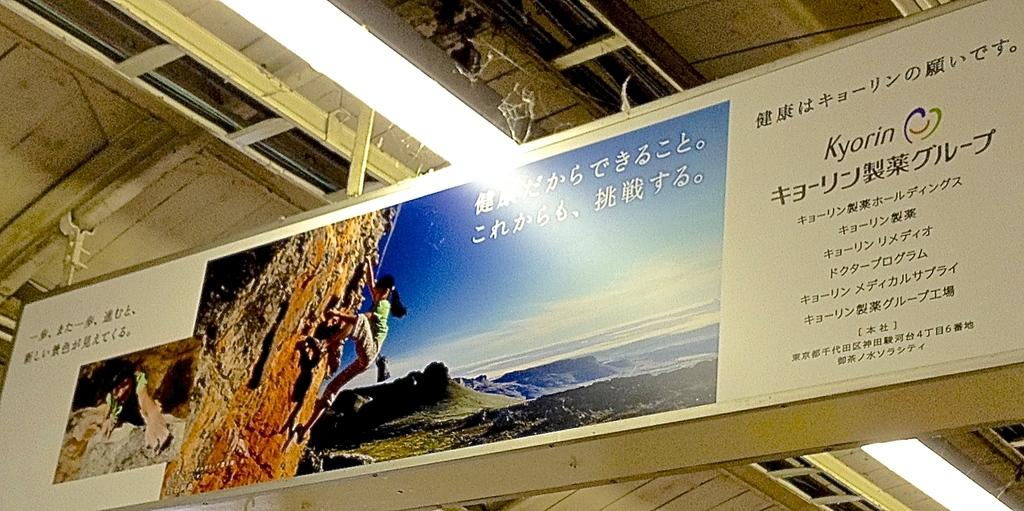<image>
Describe the image concisely. A billboard that says Kyorin on it and a lot of other words in a foreign language with a beach scene on it. 